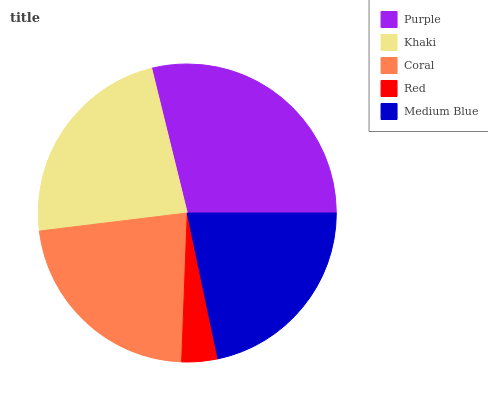Is Red the minimum?
Answer yes or no. Yes. Is Purple the maximum?
Answer yes or no. Yes. Is Khaki the minimum?
Answer yes or no. No. Is Khaki the maximum?
Answer yes or no. No. Is Purple greater than Khaki?
Answer yes or no. Yes. Is Khaki less than Purple?
Answer yes or no. Yes. Is Khaki greater than Purple?
Answer yes or no. No. Is Purple less than Khaki?
Answer yes or no. No. Is Coral the high median?
Answer yes or no. Yes. Is Coral the low median?
Answer yes or no. Yes. Is Khaki the high median?
Answer yes or no. No. Is Purple the low median?
Answer yes or no. No. 